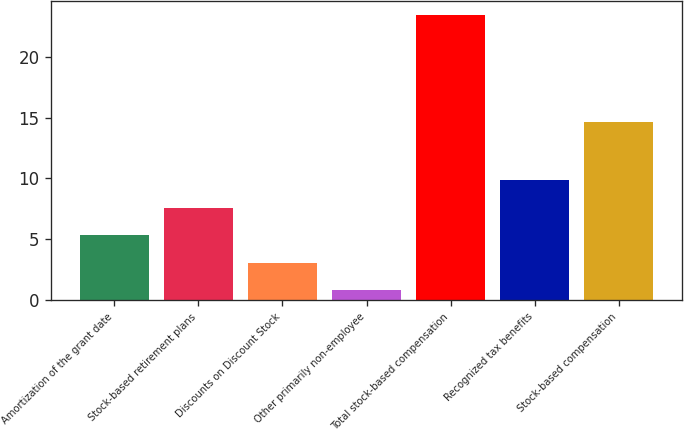Convert chart. <chart><loc_0><loc_0><loc_500><loc_500><bar_chart><fcel>Amortization of the grant date<fcel>Stock-based retirement plans<fcel>Discounts on Discount Stock<fcel>Other primarily non-employee<fcel>Total stock-based compensation<fcel>Recognized tax benefits<fcel>Stock-based compensation<nl><fcel>5.32<fcel>7.58<fcel>3.06<fcel>0.8<fcel>23.4<fcel>9.84<fcel>14.6<nl></chart> 